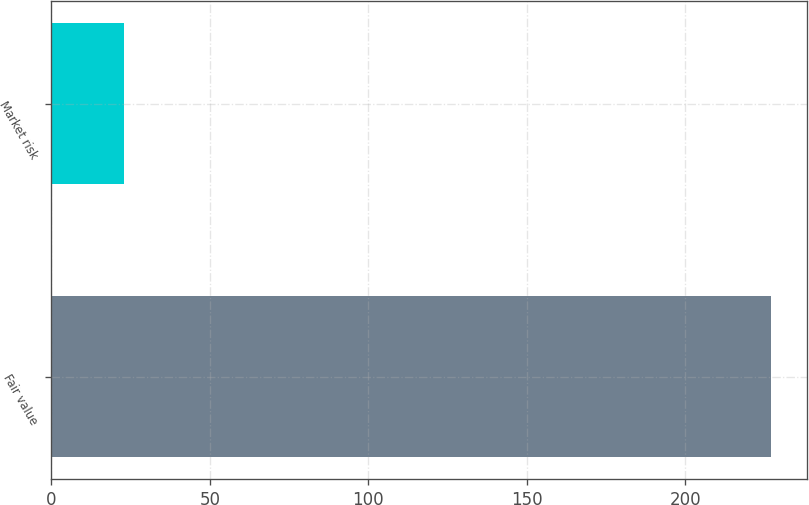<chart> <loc_0><loc_0><loc_500><loc_500><bar_chart><fcel>Fair value<fcel>Market risk<nl><fcel>227<fcel>23<nl></chart> 